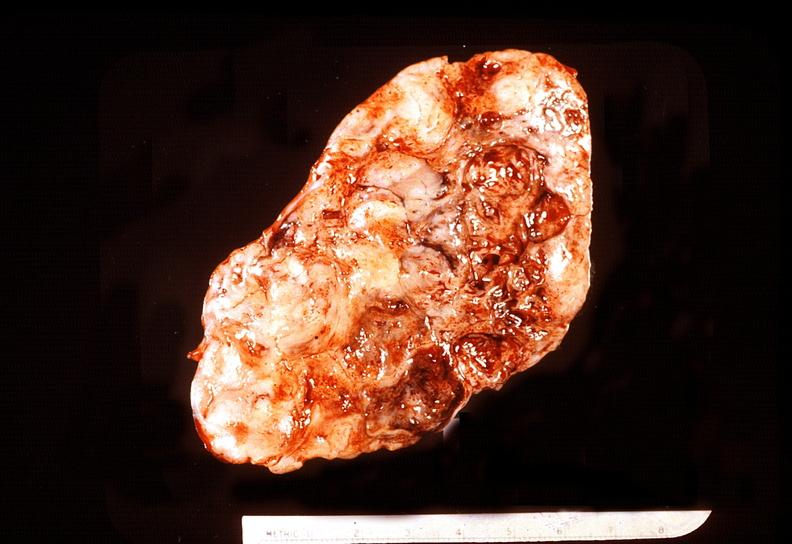s endocrine present?
Answer the question using a single word or phrase. Yes 